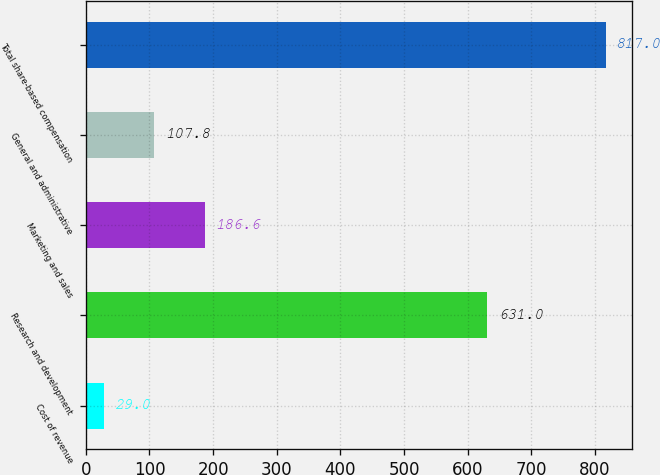Convert chart to OTSL. <chart><loc_0><loc_0><loc_500><loc_500><bar_chart><fcel>Cost of revenue<fcel>Research and development<fcel>Marketing and sales<fcel>General and administrative<fcel>Total share-based compensation<nl><fcel>29<fcel>631<fcel>186.6<fcel>107.8<fcel>817<nl></chart> 